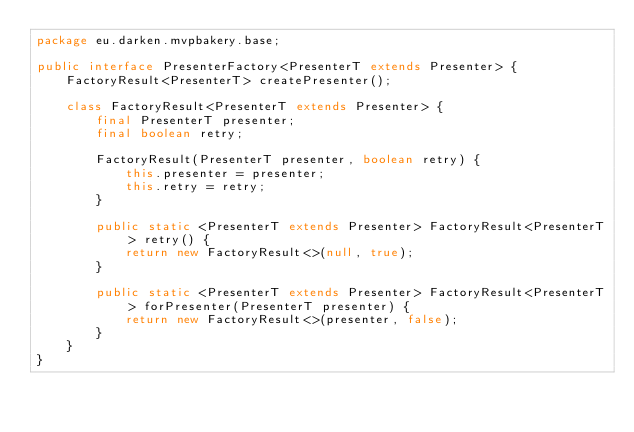Convert code to text. <code><loc_0><loc_0><loc_500><loc_500><_Java_>package eu.darken.mvpbakery.base;

public interface PresenterFactory<PresenterT extends Presenter> {
    FactoryResult<PresenterT> createPresenter();

    class FactoryResult<PresenterT extends Presenter> {
        final PresenterT presenter;
        final boolean retry;

        FactoryResult(PresenterT presenter, boolean retry) {
            this.presenter = presenter;
            this.retry = retry;
        }

        public static <PresenterT extends Presenter> FactoryResult<PresenterT> retry() {
            return new FactoryResult<>(null, true);
        }

        public static <PresenterT extends Presenter> FactoryResult<PresenterT> forPresenter(PresenterT presenter) {
            return new FactoryResult<>(presenter, false);
        }
    }
}
</code> 